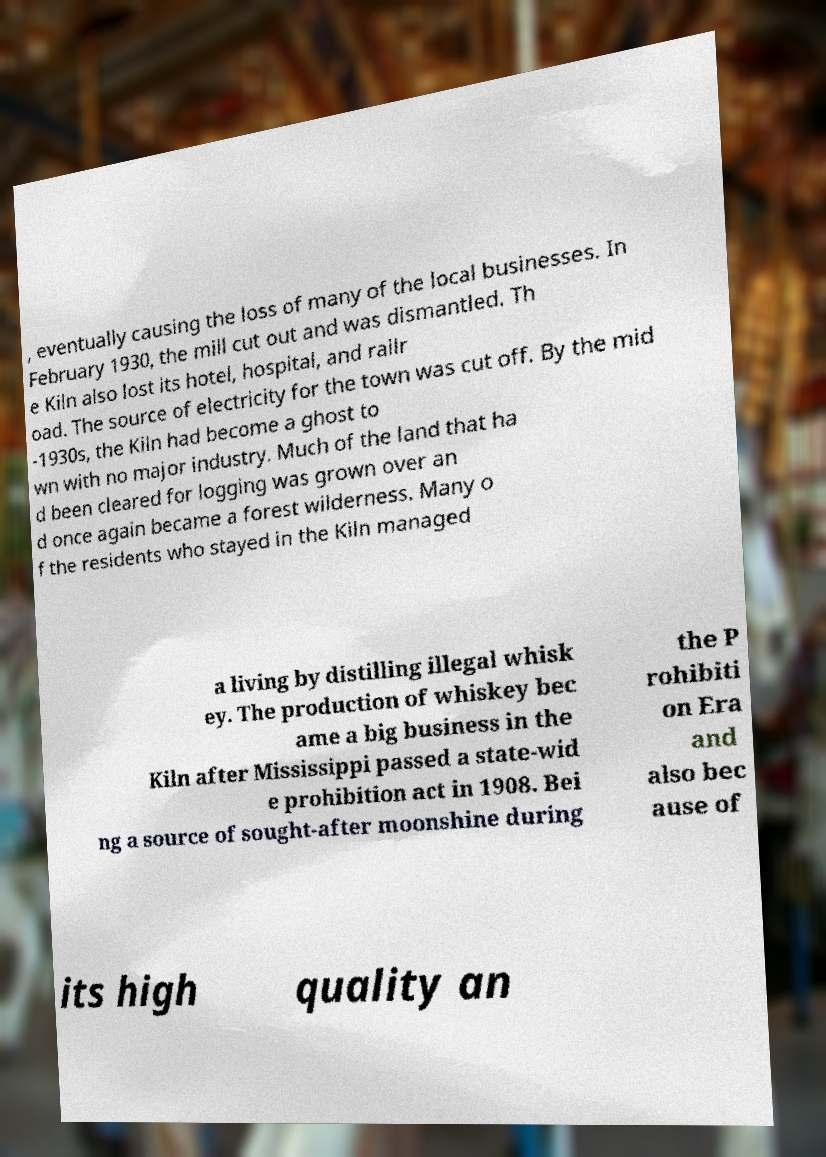There's text embedded in this image that I need extracted. Can you transcribe it verbatim? , eventually causing the loss of many of the local businesses. In February 1930, the mill cut out and was dismantled. Th e Kiln also lost its hotel, hospital, and railr oad. The source of electricity for the town was cut off. By the mid -1930s, the Kiln had become a ghost to wn with no major industry. Much of the land that ha d been cleared for logging was grown over an d once again became a forest wilderness. Many o f the residents who stayed in the Kiln managed a living by distilling illegal whisk ey. The production of whiskey bec ame a big business in the Kiln after Mississippi passed a state-wid e prohibition act in 1908. Bei ng a source of sought-after moonshine during the P rohibiti on Era and also bec ause of its high quality an 